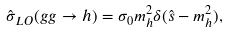<formula> <loc_0><loc_0><loc_500><loc_500>\hat { \sigma } _ { L O } ( g g \rightarrow h ) = \sigma _ { 0 } m ^ { 2 } _ { h } \delta ( \hat { s } - m ^ { 2 } _ { h } ) ,</formula> 